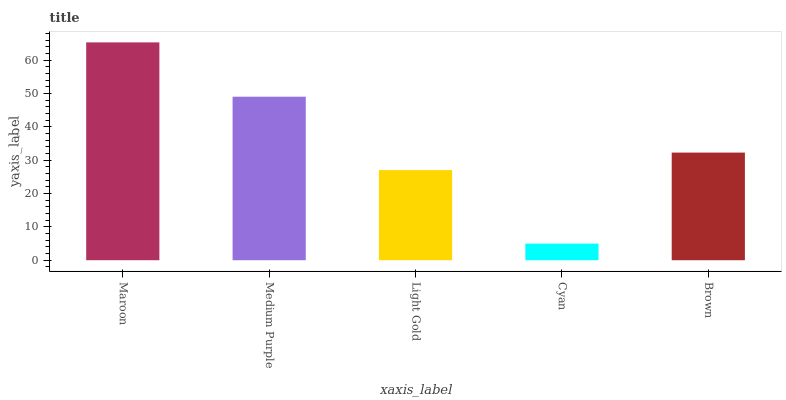Is Cyan the minimum?
Answer yes or no. Yes. Is Maroon the maximum?
Answer yes or no. Yes. Is Medium Purple the minimum?
Answer yes or no. No. Is Medium Purple the maximum?
Answer yes or no. No. Is Maroon greater than Medium Purple?
Answer yes or no. Yes. Is Medium Purple less than Maroon?
Answer yes or no. Yes. Is Medium Purple greater than Maroon?
Answer yes or no. No. Is Maroon less than Medium Purple?
Answer yes or no. No. Is Brown the high median?
Answer yes or no. Yes. Is Brown the low median?
Answer yes or no. Yes. Is Maroon the high median?
Answer yes or no. No. Is Cyan the low median?
Answer yes or no. No. 